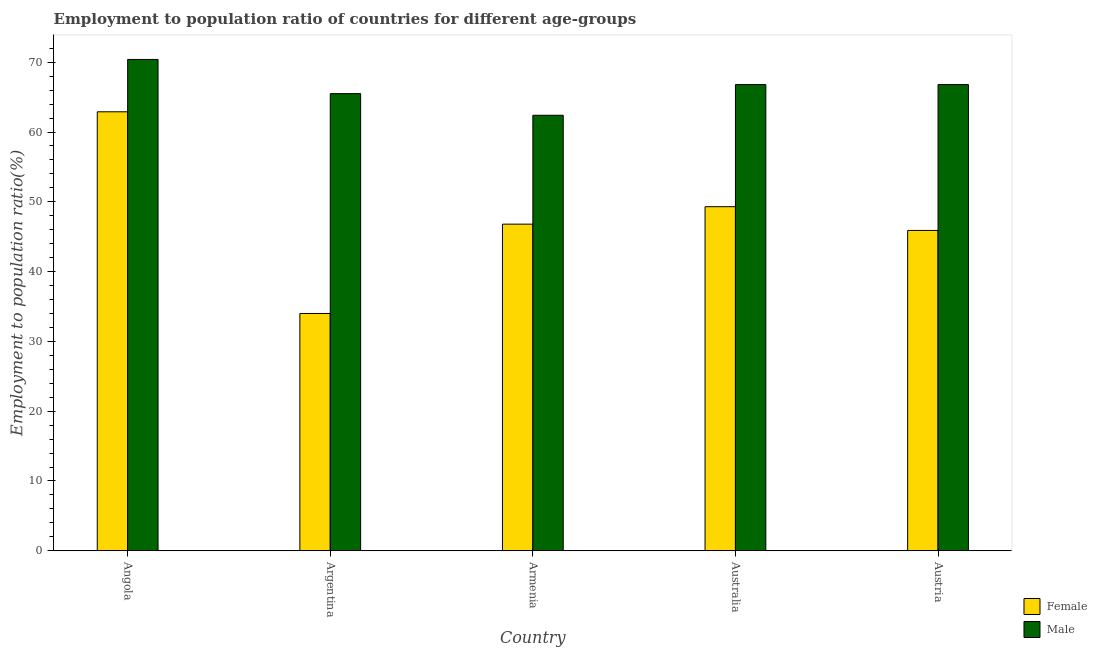How many groups of bars are there?
Provide a short and direct response. 5. Are the number of bars per tick equal to the number of legend labels?
Ensure brevity in your answer.  Yes. Are the number of bars on each tick of the X-axis equal?
Your answer should be compact. Yes. What is the label of the 4th group of bars from the left?
Provide a succinct answer. Australia. In how many cases, is the number of bars for a given country not equal to the number of legend labels?
Keep it short and to the point. 0. What is the employment to population ratio(male) in Angola?
Keep it short and to the point. 70.4. Across all countries, what is the maximum employment to population ratio(female)?
Keep it short and to the point. 62.9. Across all countries, what is the minimum employment to population ratio(female)?
Ensure brevity in your answer.  34. In which country was the employment to population ratio(male) maximum?
Your answer should be very brief. Angola. What is the total employment to population ratio(male) in the graph?
Ensure brevity in your answer.  331.9. What is the difference between the employment to population ratio(female) in Australia and that in Austria?
Ensure brevity in your answer.  3.4. What is the difference between the employment to population ratio(male) in Argentina and the employment to population ratio(female) in Armenia?
Offer a terse response. 18.7. What is the average employment to population ratio(male) per country?
Give a very brief answer. 66.38. What is the difference between the employment to population ratio(female) and employment to population ratio(male) in Australia?
Give a very brief answer. -17.5. In how many countries, is the employment to population ratio(female) greater than 34 %?
Your response must be concise. 4. What is the ratio of the employment to population ratio(male) in Argentina to that in Austria?
Make the answer very short. 0.98. Is the difference between the employment to population ratio(male) in Argentina and Armenia greater than the difference between the employment to population ratio(female) in Argentina and Armenia?
Offer a very short reply. Yes. What is the difference between the highest and the second highest employment to population ratio(female)?
Provide a succinct answer. 13.6. What is the difference between the highest and the lowest employment to population ratio(female)?
Keep it short and to the point. 28.9. Is the sum of the employment to population ratio(male) in Argentina and Australia greater than the maximum employment to population ratio(female) across all countries?
Keep it short and to the point. Yes. How many bars are there?
Your response must be concise. 10. Are all the bars in the graph horizontal?
Make the answer very short. No. What is the difference between two consecutive major ticks on the Y-axis?
Your answer should be compact. 10. Does the graph contain any zero values?
Offer a terse response. No. Where does the legend appear in the graph?
Provide a succinct answer. Bottom right. How are the legend labels stacked?
Offer a very short reply. Vertical. What is the title of the graph?
Offer a very short reply. Employment to population ratio of countries for different age-groups. What is the label or title of the X-axis?
Keep it short and to the point. Country. What is the Employment to population ratio(%) in Female in Angola?
Make the answer very short. 62.9. What is the Employment to population ratio(%) of Male in Angola?
Your answer should be very brief. 70.4. What is the Employment to population ratio(%) in Male in Argentina?
Keep it short and to the point. 65.5. What is the Employment to population ratio(%) of Female in Armenia?
Make the answer very short. 46.8. What is the Employment to population ratio(%) of Male in Armenia?
Ensure brevity in your answer.  62.4. What is the Employment to population ratio(%) of Female in Australia?
Keep it short and to the point. 49.3. What is the Employment to population ratio(%) of Male in Australia?
Provide a succinct answer. 66.8. What is the Employment to population ratio(%) in Female in Austria?
Offer a terse response. 45.9. What is the Employment to population ratio(%) of Male in Austria?
Your response must be concise. 66.8. Across all countries, what is the maximum Employment to population ratio(%) of Female?
Make the answer very short. 62.9. Across all countries, what is the maximum Employment to population ratio(%) of Male?
Your answer should be compact. 70.4. Across all countries, what is the minimum Employment to population ratio(%) in Male?
Make the answer very short. 62.4. What is the total Employment to population ratio(%) of Female in the graph?
Keep it short and to the point. 238.9. What is the total Employment to population ratio(%) of Male in the graph?
Provide a short and direct response. 331.9. What is the difference between the Employment to population ratio(%) of Female in Angola and that in Argentina?
Provide a succinct answer. 28.9. What is the difference between the Employment to population ratio(%) in Male in Angola and that in Armenia?
Your response must be concise. 8. What is the difference between the Employment to population ratio(%) in Female in Angola and that in Australia?
Ensure brevity in your answer.  13.6. What is the difference between the Employment to population ratio(%) of Male in Angola and that in Austria?
Your answer should be very brief. 3.6. What is the difference between the Employment to population ratio(%) of Female in Argentina and that in Armenia?
Ensure brevity in your answer.  -12.8. What is the difference between the Employment to population ratio(%) of Male in Argentina and that in Armenia?
Give a very brief answer. 3.1. What is the difference between the Employment to population ratio(%) of Female in Argentina and that in Australia?
Offer a very short reply. -15.3. What is the difference between the Employment to population ratio(%) of Female in Armenia and that in Australia?
Offer a terse response. -2.5. What is the difference between the Employment to population ratio(%) of Female in Armenia and that in Austria?
Your answer should be compact. 0.9. What is the difference between the Employment to population ratio(%) in Male in Australia and that in Austria?
Offer a very short reply. 0. What is the difference between the Employment to population ratio(%) of Female in Angola and the Employment to population ratio(%) of Male in Austria?
Make the answer very short. -3.9. What is the difference between the Employment to population ratio(%) of Female in Argentina and the Employment to population ratio(%) of Male in Armenia?
Your response must be concise. -28.4. What is the difference between the Employment to population ratio(%) of Female in Argentina and the Employment to population ratio(%) of Male in Australia?
Offer a terse response. -32.8. What is the difference between the Employment to population ratio(%) of Female in Argentina and the Employment to population ratio(%) of Male in Austria?
Offer a terse response. -32.8. What is the difference between the Employment to population ratio(%) in Female in Armenia and the Employment to population ratio(%) in Male in Australia?
Provide a succinct answer. -20. What is the difference between the Employment to population ratio(%) of Female in Armenia and the Employment to population ratio(%) of Male in Austria?
Give a very brief answer. -20. What is the difference between the Employment to population ratio(%) of Female in Australia and the Employment to population ratio(%) of Male in Austria?
Provide a short and direct response. -17.5. What is the average Employment to population ratio(%) of Female per country?
Offer a very short reply. 47.78. What is the average Employment to population ratio(%) of Male per country?
Give a very brief answer. 66.38. What is the difference between the Employment to population ratio(%) in Female and Employment to population ratio(%) in Male in Angola?
Your answer should be compact. -7.5. What is the difference between the Employment to population ratio(%) of Female and Employment to population ratio(%) of Male in Argentina?
Keep it short and to the point. -31.5. What is the difference between the Employment to population ratio(%) of Female and Employment to population ratio(%) of Male in Armenia?
Provide a short and direct response. -15.6. What is the difference between the Employment to population ratio(%) in Female and Employment to population ratio(%) in Male in Australia?
Ensure brevity in your answer.  -17.5. What is the difference between the Employment to population ratio(%) of Female and Employment to population ratio(%) of Male in Austria?
Provide a succinct answer. -20.9. What is the ratio of the Employment to population ratio(%) in Female in Angola to that in Argentina?
Offer a terse response. 1.85. What is the ratio of the Employment to population ratio(%) of Male in Angola to that in Argentina?
Offer a very short reply. 1.07. What is the ratio of the Employment to population ratio(%) in Female in Angola to that in Armenia?
Your answer should be very brief. 1.34. What is the ratio of the Employment to population ratio(%) of Male in Angola to that in Armenia?
Your answer should be very brief. 1.13. What is the ratio of the Employment to population ratio(%) in Female in Angola to that in Australia?
Provide a short and direct response. 1.28. What is the ratio of the Employment to population ratio(%) of Male in Angola to that in Australia?
Provide a short and direct response. 1.05. What is the ratio of the Employment to population ratio(%) in Female in Angola to that in Austria?
Your answer should be very brief. 1.37. What is the ratio of the Employment to population ratio(%) of Male in Angola to that in Austria?
Give a very brief answer. 1.05. What is the ratio of the Employment to population ratio(%) of Female in Argentina to that in Armenia?
Provide a short and direct response. 0.73. What is the ratio of the Employment to population ratio(%) of Male in Argentina to that in Armenia?
Keep it short and to the point. 1.05. What is the ratio of the Employment to population ratio(%) in Female in Argentina to that in Australia?
Offer a terse response. 0.69. What is the ratio of the Employment to population ratio(%) of Male in Argentina to that in Australia?
Provide a succinct answer. 0.98. What is the ratio of the Employment to population ratio(%) in Female in Argentina to that in Austria?
Provide a succinct answer. 0.74. What is the ratio of the Employment to population ratio(%) of Male in Argentina to that in Austria?
Your answer should be compact. 0.98. What is the ratio of the Employment to population ratio(%) in Female in Armenia to that in Australia?
Offer a terse response. 0.95. What is the ratio of the Employment to population ratio(%) of Male in Armenia to that in Australia?
Your answer should be compact. 0.93. What is the ratio of the Employment to population ratio(%) in Female in Armenia to that in Austria?
Offer a terse response. 1.02. What is the ratio of the Employment to population ratio(%) of Male in Armenia to that in Austria?
Make the answer very short. 0.93. What is the ratio of the Employment to population ratio(%) in Female in Australia to that in Austria?
Your answer should be compact. 1.07. What is the difference between the highest and the second highest Employment to population ratio(%) in Male?
Provide a succinct answer. 3.6. What is the difference between the highest and the lowest Employment to population ratio(%) in Female?
Your answer should be very brief. 28.9. 